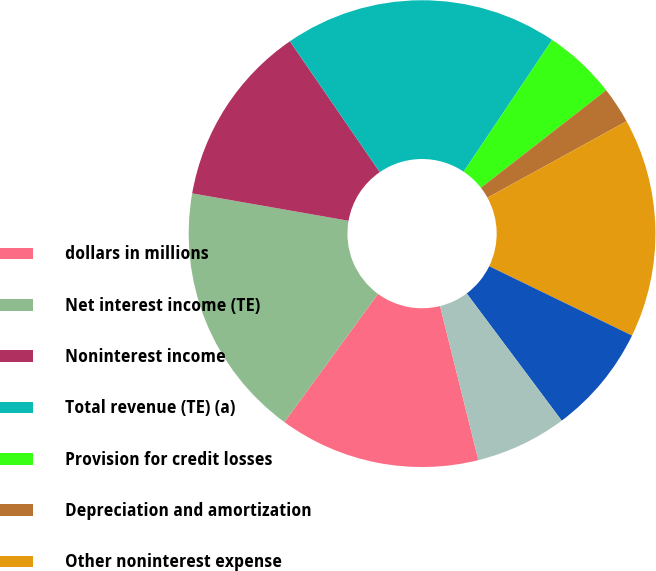<chart> <loc_0><loc_0><loc_500><loc_500><pie_chart><fcel>dollars in millions<fcel>Net interest income (TE)<fcel>Noninterest income<fcel>Total revenue (TE) (a)<fcel>Provision for credit losses<fcel>Depreciation and amortization<fcel>Other noninterest expense<fcel>Income (loss) from continuing<fcel>Allocated income taxes<nl><fcel>13.92%<fcel>17.72%<fcel>12.66%<fcel>18.99%<fcel>5.06%<fcel>2.53%<fcel>15.19%<fcel>7.6%<fcel>6.33%<nl></chart> 